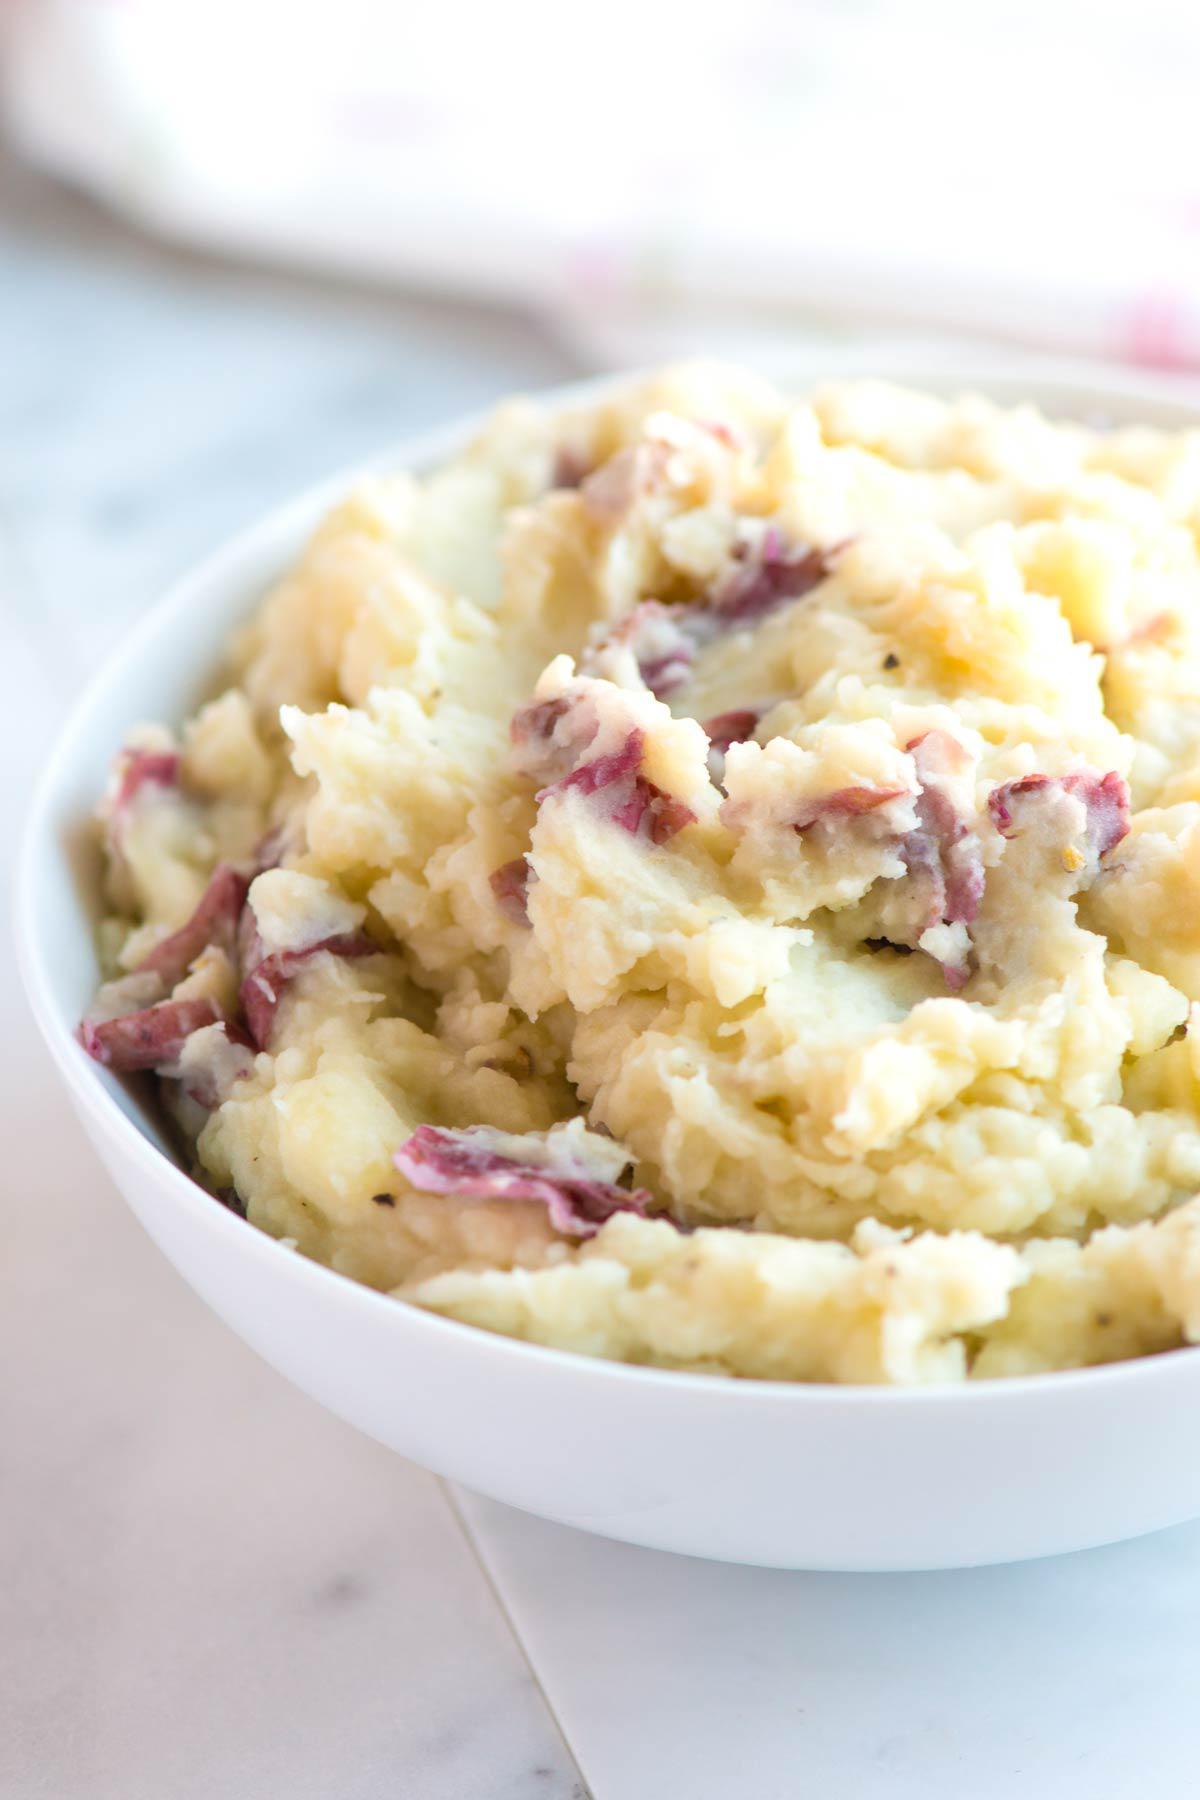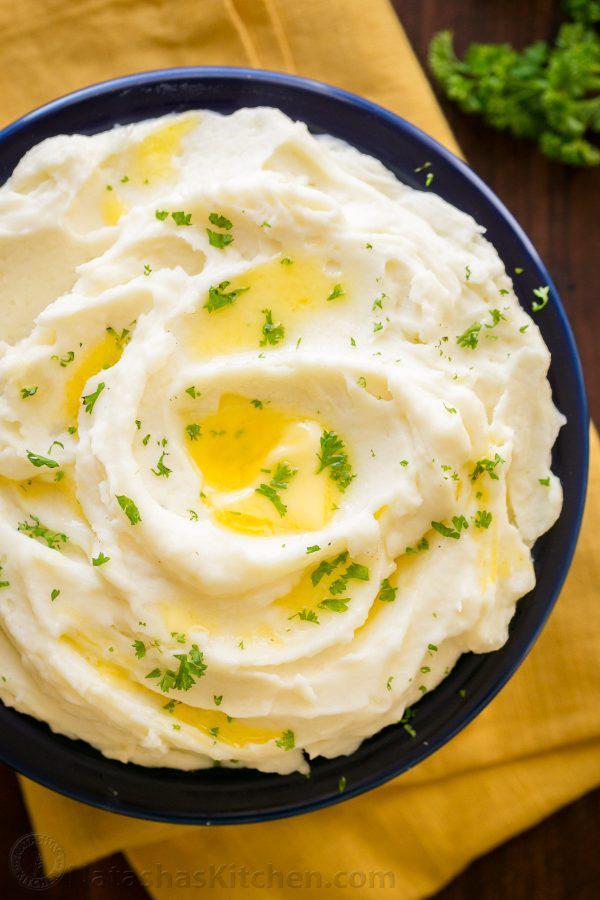The first image is the image on the left, the second image is the image on the right. For the images shown, is this caption "One image has an eating utensil." true? Answer yes or no. No. 